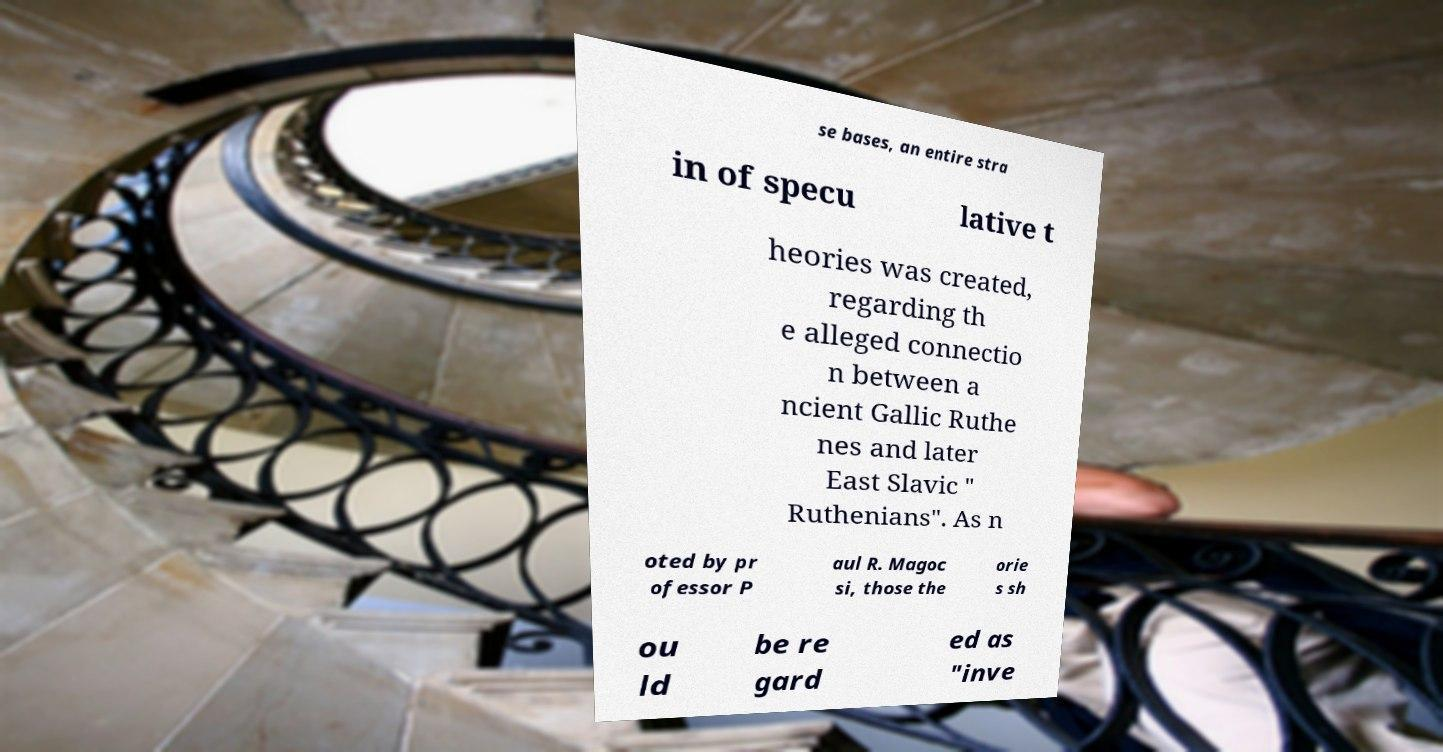What messages or text are displayed in this image? I need them in a readable, typed format. se bases, an entire stra in of specu lative t heories was created, regarding th e alleged connectio n between a ncient Gallic Ruthe nes and later East Slavic " Ruthenians". As n oted by pr ofessor P aul R. Magoc si, those the orie s sh ou ld be re gard ed as "inve 